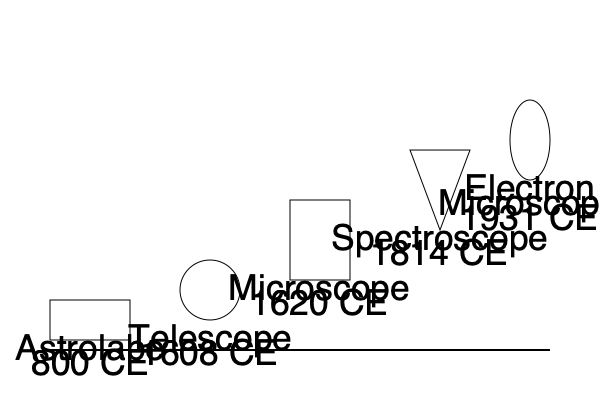Analyze the timeline of scientific instruments shown in the image. Which instrument marked a significant shift from observing macroscopic objects to microscopic entities, and how did this impact the field of biology? 1. The timeline shows the evolution of scientific instruments from 800 CE to 1931 CE.

2. The instruments depicted are:
   - Astrolabe (800 CE): Used for astronomical measurements
   - Telescope (1608 CE): Enabled observation of distant celestial objects
   - Microscope (1620 CE): Allowed visualization of microscopic entities
   - Spectroscope (1814 CE): Used for analyzing light spectra
   - Electron Microscope (1931 CE): Provided even higher magnification than light microscopes

3. The microscope, invented around 1620 CE, marked a significant shift in scientific observation capabilities.

4. Before the microscope, scientists were limited to observing macroscopic objects visible to the naked eye.

5. The microscope allowed scientists to visualize microscopic entities such as cells, bacteria, and other microorganisms for the first time.

6. This shift had a profound impact on biology:
   - It led to the discovery of cells, the fundamental units of life
   - It enabled the study of microorganisms, leading to advancements in microbiology
   - It facilitated the development of cell theory, a cornerstone of modern biology
   - It allowed for detailed study of tissue structures and cellular processes

7. The microscope's invention paved the way for numerous biological discoveries and advancements in fields such as cell biology, microbiology, and histology.

8. Subsequent improvements in microscopy, culminating in the electron microscope, further expanded our ability to study biological structures at even higher magnifications.
Answer: The microscope (1620 CE), enabling visualization of cells and microorganisms. 